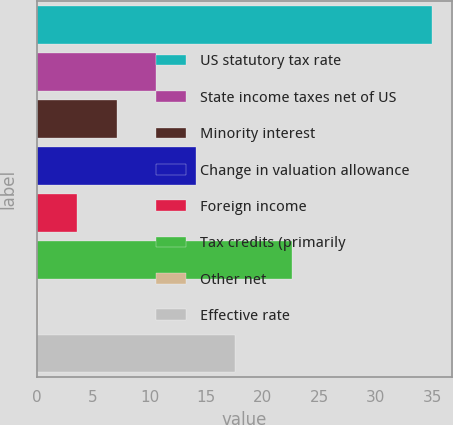Convert chart. <chart><loc_0><loc_0><loc_500><loc_500><bar_chart><fcel>US statutory tax rate<fcel>State income taxes net of US<fcel>Minority interest<fcel>Change in valuation allowance<fcel>Foreign income<fcel>Tax credits (primarily<fcel>Other net<fcel>Effective rate<nl><fcel>35<fcel>10.57<fcel>7.08<fcel>14.06<fcel>3.59<fcel>22.6<fcel>0.1<fcel>17.55<nl></chart> 